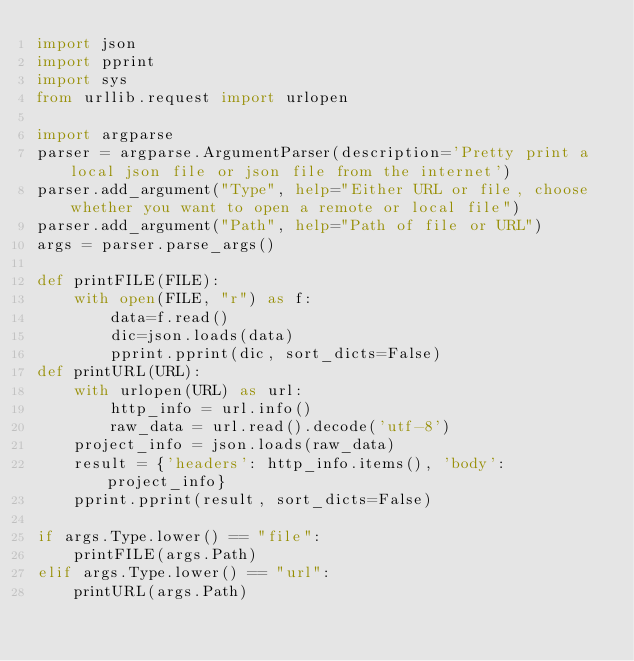Convert code to text. <code><loc_0><loc_0><loc_500><loc_500><_Python_>import json
import pprint
import sys
from urllib.request import urlopen

import argparse
parser = argparse.ArgumentParser(description='Pretty print a local json file or json file from the internet')
parser.add_argument("Type", help="Either URL or file, choose whether you want to open a remote or local file")
parser.add_argument("Path", help="Path of file or URL")
args = parser.parse_args()

def printFILE(FILE):
    with open(FILE, "r") as f:
        data=f.read()
        dic=json.loads(data)
        pprint.pprint(dic, sort_dicts=False)
def printURL(URL):
    with urlopen(URL) as url:
        http_info = url.info()
        raw_data = url.read().decode('utf-8')
    project_info = json.loads(raw_data)
    result = {'headers': http_info.items(), 'body': project_info}
    pprint.pprint(result, sort_dicts=False)

if args.Type.lower() == "file":
    printFILE(args.Path)
elif args.Type.lower() == "url":
    printURL(args.Path)
</code> 